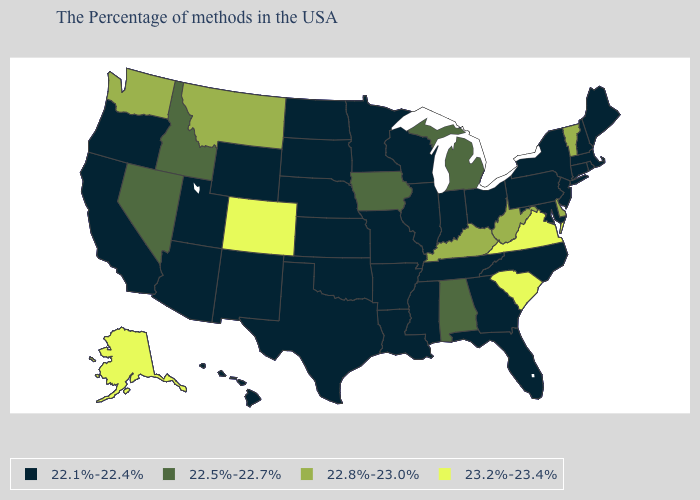What is the value of South Dakota?
Be succinct. 22.1%-22.4%. Does the map have missing data?
Be succinct. No. What is the value of Alaska?
Give a very brief answer. 23.2%-23.4%. How many symbols are there in the legend?
Write a very short answer. 4. Is the legend a continuous bar?
Be succinct. No. Name the states that have a value in the range 22.5%-22.7%?
Write a very short answer. Michigan, Alabama, Iowa, Idaho, Nevada. What is the value of Maine?
Write a very short answer. 22.1%-22.4%. Does Alaska have the lowest value in the West?
Answer briefly. No. Is the legend a continuous bar?
Answer briefly. No. What is the lowest value in the MidWest?
Write a very short answer. 22.1%-22.4%. Does New York have the lowest value in the Northeast?
Quick response, please. Yes. What is the lowest value in states that border Alabama?
Concise answer only. 22.1%-22.4%. What is the value of Nebraska?
Short answer required. 22.1%-22.4%. Name the states that have a value in the range 23.2%-23.4%?
Write a very short answer. Virginia, South Carolina, Colorado, Alaska. 